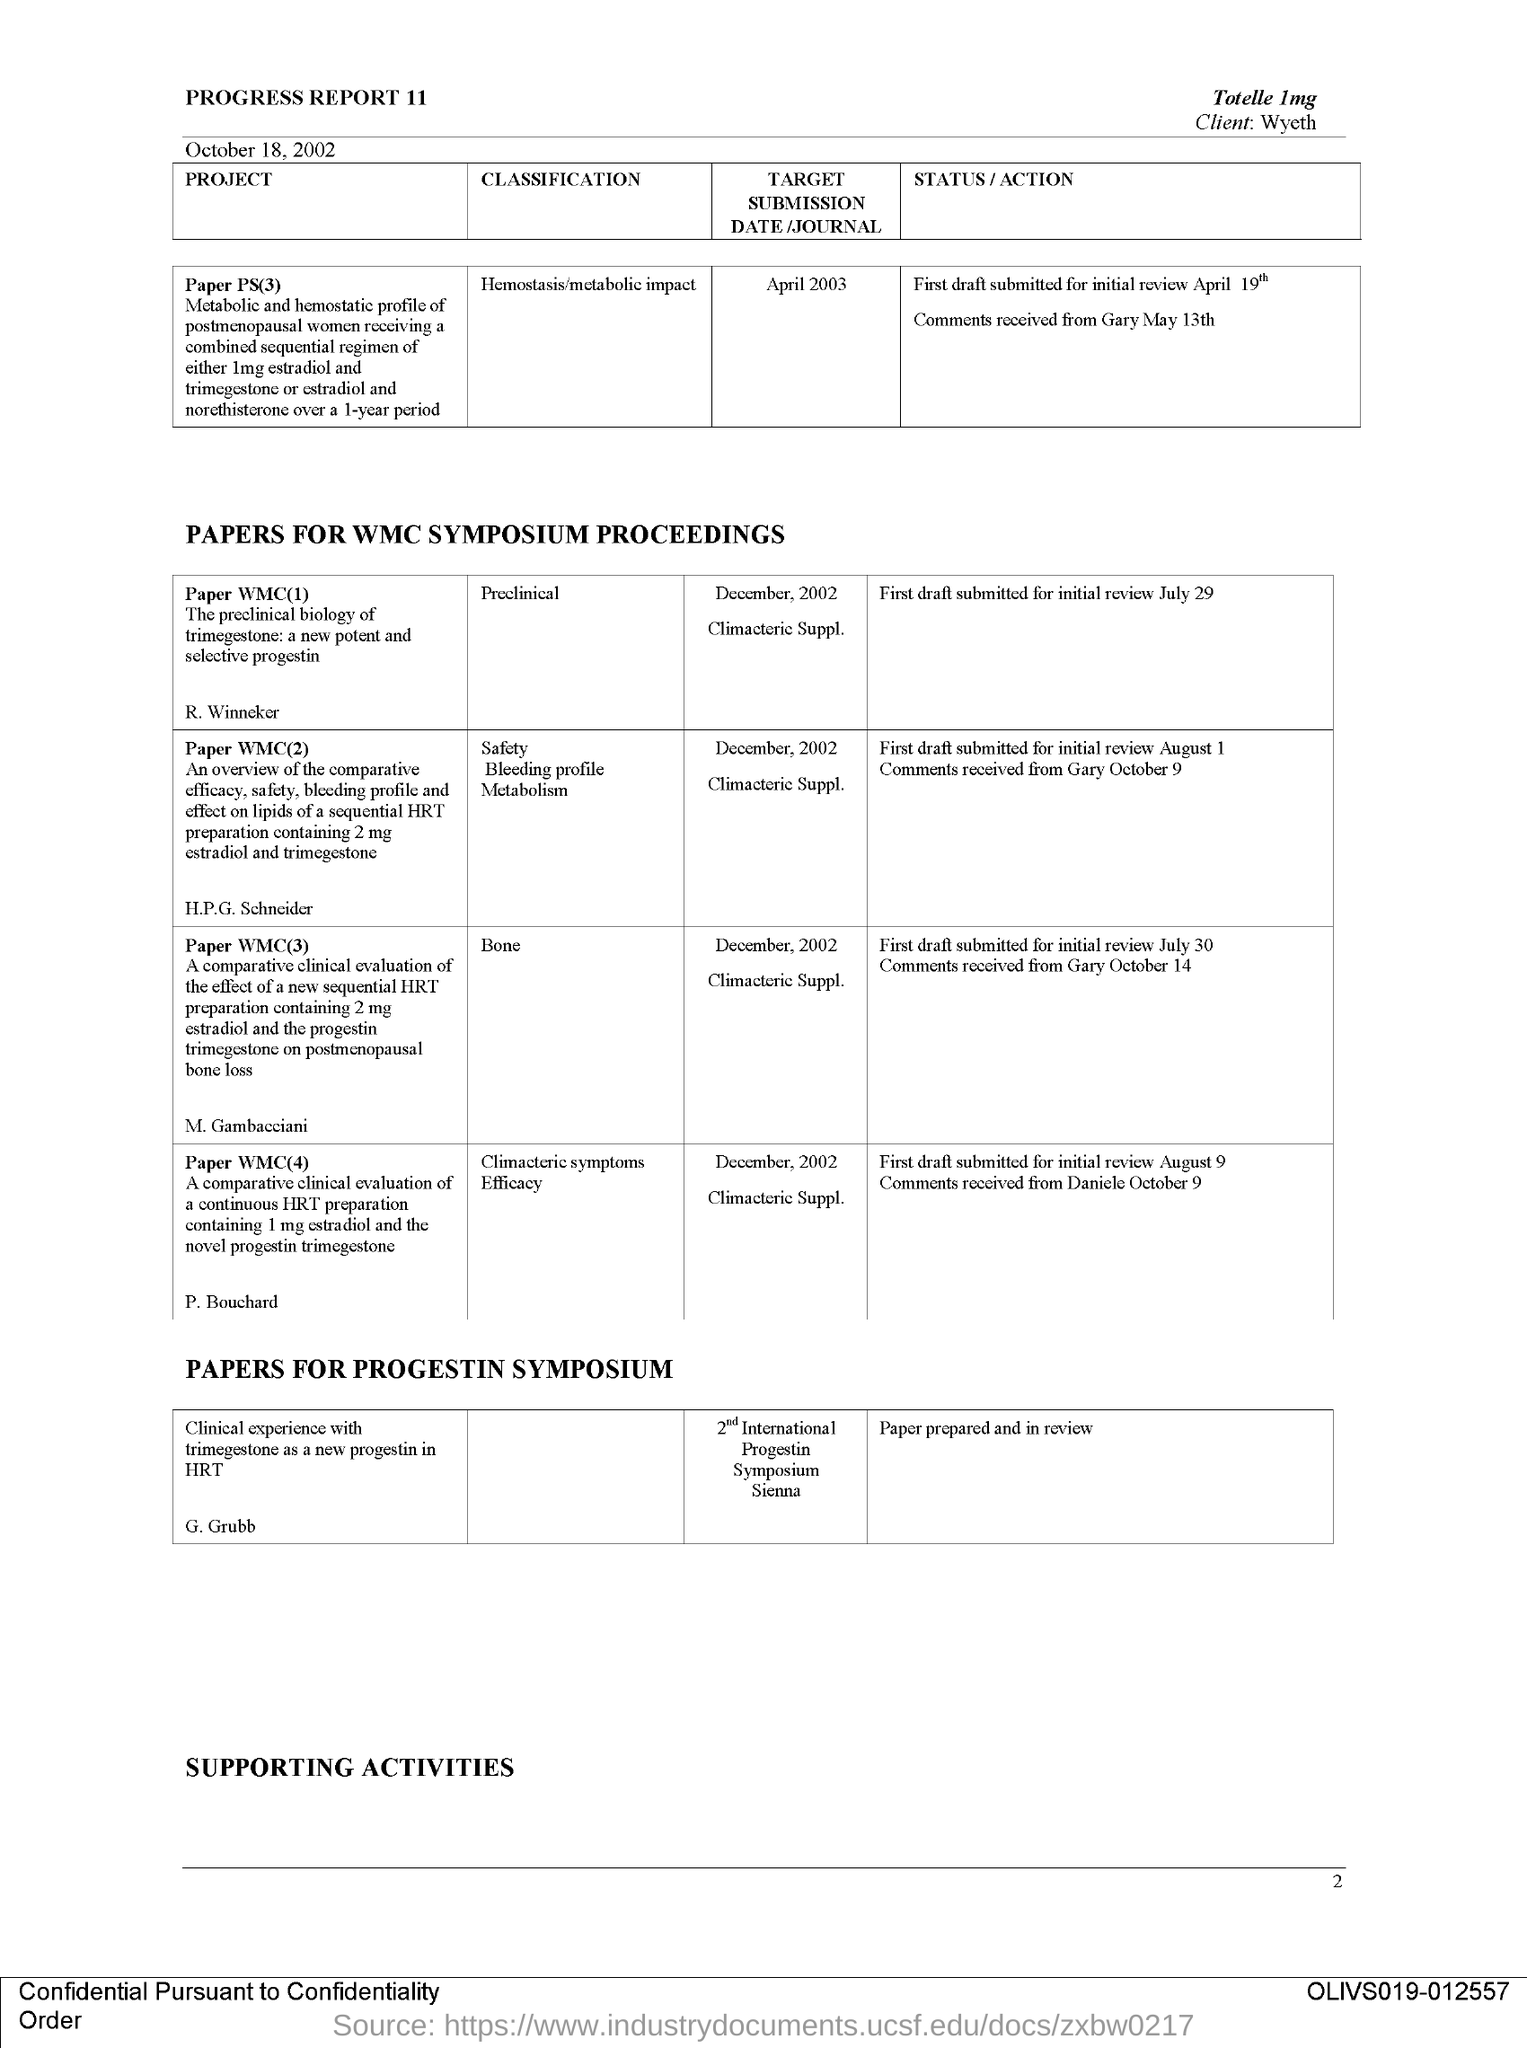Point out several critical features in this image. The date of submission of the project paper titled "Paper PS(3)" is April 2003. The page number is 2," the speaker declared. Paper WMC(1) is classified as preclinical. Paper WMC(3) is classified as belonging to the category of bone. The second title in the document is "Papers for WMC symposium proceedings.. 